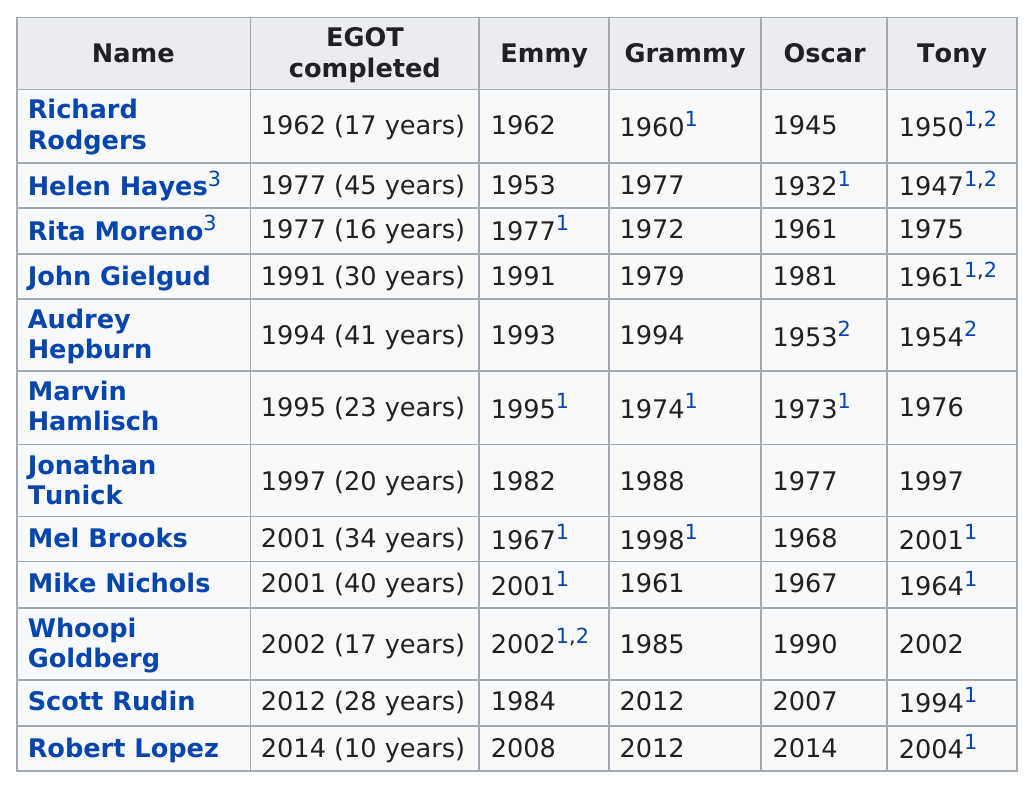Specify some key components in this picture. It is declared that Scott Rudin took less than 30 years to complete Egot. Five actors and actresses took 20 years or less to complete their work on EGOT. It is known that Richard Rodgers was the first person to complete egot the earliest year. It is evident that Robert Lopez took the least amount of time to complete the egot challenge, as stated by the person who completed it before him. Helen Hayes is the actress who took the most years to complete EGOT, having received all four awards. 